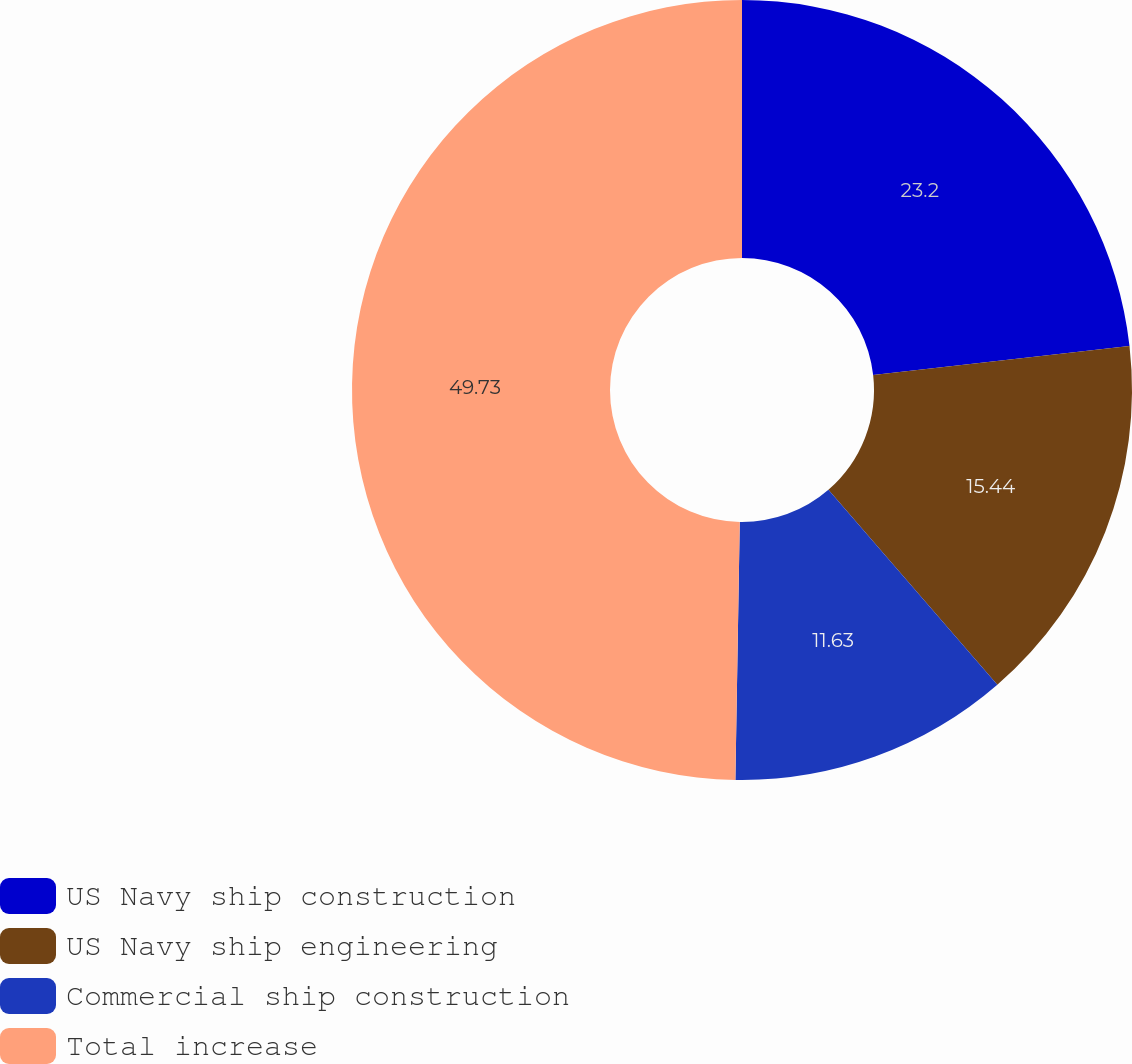Convert chart to OTSL. <chart><loc_0><loc_0><loc_500><loc_500><pie_chart><fcel>US Navy ship construction<fcel>US Navy ship engineering<fcel>Commercial ship construction<fcel>Total increase<nl><fcel>23.2%<fcel>15.44%<fcel>11.63%<fcel>49.73%<nl></chart> 